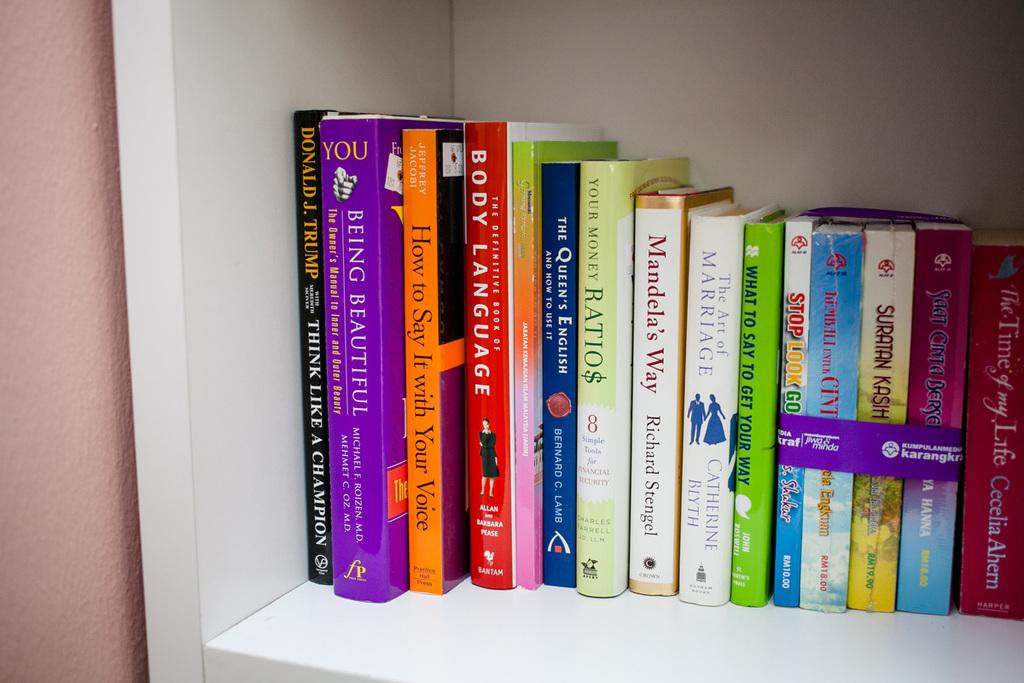What type of objects can be seen in the image? There are many colorful books in the image. Where are the books located? The books are on a white color shelf. What can be seen to the left of the shelf? There is a wall visible to the left of the shelf. Can you see a bat hanging from the wall in the image? There is no bat present in the image; it only features colorful books on a white shelf and a wall to the left. 